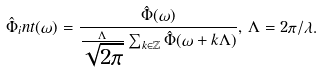<formula> <loc_0><loc_0><loc_500><loc_500>\hat { \Phi } _ { i } n t ( \omega ) = \frac { \hat { \Phi } ( \omega ) } { \frac { \Lambda } { \sqrt { 2 \pi } } \sum _ { k \in { \mathbb { Z } } } \hat { \Phi } ( \omega + k \Lambda ) } , \, \Lambda = 2 \pi / \lambda .</formula> 